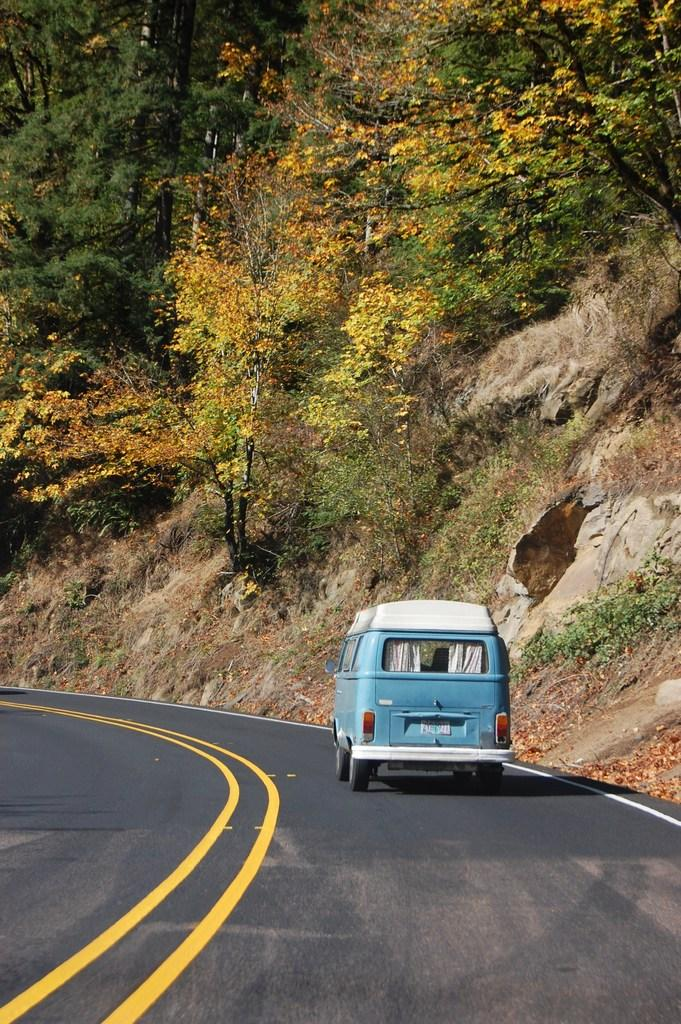What is on the road in the image? There is a vehicle on the road in the image. What colors can be seen on the vehicle? The vehicle is blue and white in color. What can be seen in the background of the image? There are trees and a mountain visible in the background of the image. What type of thunder can be heard in the image? There is no thunder present in the image, as it is a visual representation and does not include sound. 